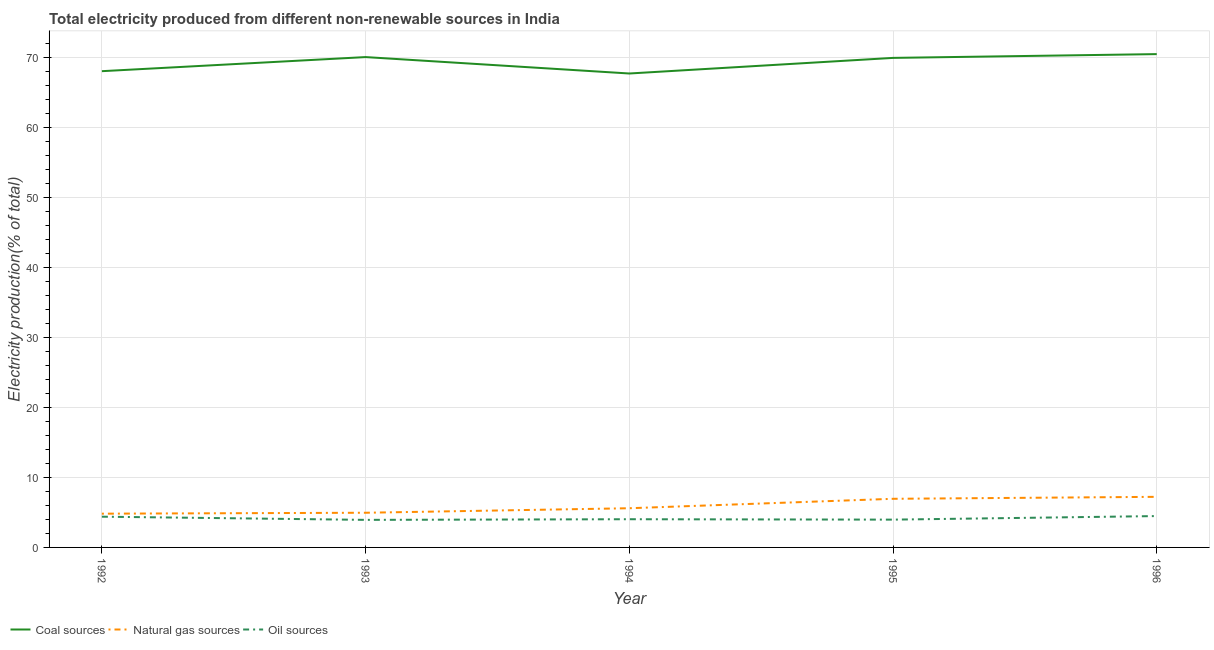How many different coloured lines are there?
Offer a terse response. 3. Does the line corresponding to percentage of electricity produced by oil sources intersect with the line corresponding to percentage of electricity produced by coal?
Give a very brief answer. No. Is the number of lines equal to the number of legend labels?
Offer a terse response. Yes. What is the percentage of electricity produced by oil sources in 1996?
Give a very brief answer. 4.48. Across all years, what is the maximum percentage of electricity produced by oil sources?
Keep it short and to the point. 4.48. Across all years, what is the minimum percentage of electricity produced by natural gas?
Provide a succinct answer. 4.82. In which year was the percentage of electricity produced by coal minimum?
Your answer should be very brief. 1994. What is the total percentage of electricity produced by natural gas in the graph?
Offer a terse response. 29.55. What is the difference between the percentage of electricity produced by oil sources in 1995 and that in 1996?
Your answer should be very brief. -0.51. What is the difference between the percentage of electricity produced by coal in 1995 and the percentage of electricity produced by oil sources in 1996?
Provide a short and direct response. 65.46. What is the average percentage of electricity produced by coal per year?
Give a very brief answer. 69.24. In the year 1992, what is the difference between the percentage of electricity produced by natural gas and percentage of electricity produced by coal?
Your response must be concise. -63.22. What is the ratio of the percentage of electricity produced by coal in 1992 to that in 1995?
Offer a very short reply. 0.97. Is the percentage of electricity produced by natural gas in 1993 less than that in 1994?
Provide a short and direct response. Yes. Is the difference between the percentage of electricity produced by natural gas in 1992 and 1995 greater than the difference between the percentage of electricity produced by coal in 1992 and 1995?
Offer a very short reply. No. What is the difference between the highest and the second highest percentage of electricity produced by natural gas?
Ensure brevity in your answer.  0.28. What is the difference between the highest and the lowest percentage of electricity produced by oil sources?
Make the answer very short. 0.54. Is the sum of the percentage of electricity produced by coal in 1993 and 1996 greater than the maximum percentage of electricity produced by oil sources across all years?
Give a very brief answer. Yes. Is the percentage of electricity produced by coal strictly greater than the percentage of electricity produced by oil sources over the years?
Provide a short and direct response. Yes. Is the percentage of electricity produced by natural gas strictly less than the percentage of electricity produced by oil sources over the years?
Offer a terse response. No. What is the difference between two consecutive major ticks on the Y-axis?
Your answer should be very brief. 10. Are the values on the major ticks of Y-axis written in scientific E-notation?
Offer a very short reply. No. Where does the legend appear in the graph?
Keep it short and to the point. Bottom left. How many legend labels are there?
Offer a very short reply. 3. How are the legend labels stacked?
Offer a very short reply. Horizontal. What is the title of the graph?
Keep it short and to the point. Total electricity produced from different non-renewable sources in India. What is the label or title of the X-axis?
Offer a very short reply. Year. What is the Electricity production(% of total) in Coal sources in 1992?
Your answer should be very brief. 68.04. What is the Electricity production(% of total) of Natural gas sources in 1992?
Your answer should be very brief. 4.82. What is the Electricity production(% of total) in Oil sources in 1992?
Provide a short and direct response. 4.39. What is the Electricity production(% of total) in Coal sources in 1993?
Provide a succinct answer. 70.05. What is the Electricity production(% of total) of Natural gas sources in 1993?
Offer a terse response. 4.95. What is the Electricity production(% of total) of Oil sources in 1993?
Give a very brief answer. 3.94. What is the Electricity production(% of total) in Coal sources in 1994?
Offer a very short reply. 67.71. What is the Electricity production(% of total) in Natural gas sources in 1994?
Make the answer very short. 5.6. What is the Electricity production(% of total) of Oil sources in 1994?
Ensure brevity in your answer.  4.03. What is the Electricity production(% of total) in Coal sources in 1995?
Provide a succinct answer. 69.94. What is the Electricity production(% of total) in Natural gas sources in 1995?
Provide a short and direct response. 6.95. What is the Electricity production(% of total) in Oil sources in 1995?
Ensure brevity in your answer.  3.97. What is the Electricity production(% of total) of Coal sources in 1996?
Your answer should be compact. 70.48. What is the Electricity production(% of total) in Natural gas sources in 1996?
Your response must be concise. 7.23. What is the Electricity production(% of total) in Oil sources in 1996?
Your response must be concise. 4.48. Across all years, what is the maximum Electricity production(% of total) of Coal sources?
Your response must be concise. 70.48. Across all years, what is the maximum Electricity production(% of total) in Natural gas sources?
Your answer should be compact. 7.23. Across all years, what is the maximum Electricity production(% of total) of Oil sources?
Your response must be concise. 4.48. Across all years, what is the minimum Electricity production(% of total) of Coal sources?
Your answer should be very brief. 67.71. Across all years, what is the minimum Electricity production(% of total) of Natural gas sources?
Your answer should be very brief. 4.82. Across all years, what is the minimum Electricity production(% of total) of Oil sources?
Your answer should be very brief. 3.94. What is the total Electricity production(% of total) of Coal sources in the graph?
Offer a very short reply. 346.21. What is the total Electricity production(% of total) of Natural gas sources in the graph?
Keep it short and to the point. 29.55. What is the total Electricity production(% of total) of Oil sources in the graph?
Ensure brevity in your answer.  20.81. What is the difference between the Electricity production(% of total) of Coal sources in 1992 and that in 1993?
Ensure brevity in your answer.  -2.01. What is the difference between the Electricity production(% of total) in Natural gas sources in 1992 and that in 1993?
Your answer should be compact. -0.13. What is the difference between the Electricity production(% of total) of Oil sources in 1992 and that in 1993?
Your answer should be very brief. 0.45. What is the difference between the Electricity production(% of total) in Coal sources in 1992 and that in 1994?
Make the answer very short. 0.33. What is the difference between the Electricity production(% of total) in Natural gas sources in 1992 and that in 1994?
Offer a terse response. -0.78. What is the difference between the Electricity production(% of total) in Oil sources in 1992 and that in 1994?
Your response must be concise. 0.36. What is the difference between the Electricity production(% of total) of Coal sources in 1992 and that in 1995?
Your response must be concise. -1.9. What is the difference between the Electricity production(% of total) of Natural gas sources in 1992 and that in 1995?
Make the answer very short. -2.13. What is the difference between the Electricity production(% of total) of Oil sources in 1992 and that in 1995?
Provide a short and direct response. 0.42. What is the difference between the Electricity production(% of total) of Coal sources in 1992 and that in 1996?
Ensure brevity in your answer.  -2.44. What is the difference between the Electricity production(% of total) of Natural gas sources in 1992 and that in 1996?
Your answer should be very brief. -2.41. What is the difference between the Electricity production(% of total) in Oil sources in 1992 and that in 1996?
Provide a succinct answer. -0.09. What is the difference between the Electricity production(% of total) of Coal sources in 1993 and that in 1994?
Provide a succinct answer. 2.35. What is the difference between the Electricity production(% of total) in Natural gas sources in 1993 and that in 1994?
Give a very brief answer. -0.64. What is the difference between the Electricity production(% of total) of Oil sources in 1993 and that in 1994?
Your answer should be compact. -0.09. What is the difference between the Electricity production(% of total) of Coal sources in 1993 and that in 1995?
Your response must be concise. 0.12. What is the difference between the Electricity production(% of total) of Natural gas sources in 1993 and that in 1995?
Keep it short and to the point. -1.99. What is the difference between the Electricity production(% of total) of Oil sources in 1993 and that in 1995?
Provide a short and direct response. -0.03. What is the difference between the Electricity production(% of total) of Coal sources in 1993 and that in 1996?
Your answer should be very brief. -0.42. What is the difference between the Electricity production(% of total) in Natural gas sources in 1993 and that in 1996?
Give a very brief answer. -2.27. What is the difference between the Electricity production(% of total) of Oil sources in 1993 and that in 1996?
Offer a terse response. -0.54. What is the difference between the Electricity production(% of total) of Coal sources in 1994 and that in 1995?
Make the answer very short. -2.23. What is the difference between the Electricity production(% of total) in Natural gas sources in 1994 and that in 1995?
Your response must be concise. -1.35. What is the difference between the Electricity production(% of total) in Oil sources in 1994 and that in 1995?
Give a very brief answer. 0.06. What is the difference between the Electricity production(% of total) of Coal sources in 1994 and that in 1996?
Provide a succinct answer. -2.77. What is the difference between the Electricity production(% of total) of Natural gas sources in 1994 and that in 1996?
Keep it short and to the point. -1.63. What is the difference between the Electricity production(% of total) of Oil sources in 1994 and that in 1996?
Your response must be concise. -0.45. What is the difference between the Electricity production(% of total) in Coal sources in 1995 and that in 1996?
Your answer should be very brief. -0.54. What is the difference between the Electricity production(% of total) of Natural gas sources in 1995 and that in 1996?
Keep it short and to the point. -0.28. What is the difference between the Electricity production(% of total) in Oil sources in 1995 and that in 1996?
Your answer should be very brief. -0.51. What is the difference between the Electricity production(% of total) of Coal sources in 1992 and the Electricity production(% of total) of Natural gas sources in 1993?
Ensure brevity in your answer.  63.08. What is the difference between the Electricity production(% of total) of Coal sources in 1992 and the Electricity production(% of total) of Oil sources in 1993?
Provide a short and direct response. 64.1. What is the difference between the Electricity production(% of total) of Natural gas sources in 1992 and the Electricity production(% of total) of Oil sources in 1993?
Your answer should be compact. 0.88. What is the difference between the Electricity production(% of total) in Coal sources in 1992 and the Electricity production(% of total) in Natural gas sources in 1994?
Your response must be concise. 62.44. What is the difference between the Electricity production(% of total) of Coal sources in 1992 and the Electricity production(% of total) of Oil sources in 1994?
Provide a short and direct response. 64.01. What is the difference between the Electricity production(% of total) of Natural gas sources in 1992 and the Electricity production(% of total) of Oil sources in 1994?
Your answer should be compact. 0.79. What is the difference between the Electricity production(% of total) of Coal sources in 1992 and the Electricity production(% of total) of Natural gas sources in 1995?
Offer a very short reply. 61.09. What is the difference between the Electricity production(% of total) in Coal sources in 1992 and the Electricity production(% of total) in Oil sources in 1995?
Offer a terse response. 64.07. What is the difference between the Electricity production(% of total) in Natural gas sources in 1992 and the Electricity production(% of total) in Oil sources in 1995?
Provide a succinct answer. 0.85. What is the difference between the Electricity production(% of total) in Coal sources in 1992 and the Electricity production(% of total) in Natural gas sources in 1996?
Offer a very short reply. 60.81. What is the difference between the Electricity production(% of total) of Coal sources in 1992 and the Electricity production(% of total) of Oil sources in 1996?
Your response must be concise. 63.56. What is the difference between the Electricity production(% of total) in Natural gas sources in 1992 and the Electricity production(% of total) in Oil sources in 1996?
Keep it short and to the point. 0.34. What is the difference between the Electricity production(% of total) of Coal sources in 1993 and the Electricity production(% of total) of Natural gas sources in 1994?
Your response must be concise. 64.45. What is the difference between the Electricity production(% of total) of Coal sources in 1993 and the Electricity production(% of total) of Oil sources in 1994?
Make the answer very short. 66.02. What is the difference between the Electricity production(% of total) in Natural gas sources in 1993 and the Electricity production(% of total) in Oil sources in 1994?
Your answer should be compact. 0.93. What is the difference between the Electricity production(% of total) in Coal sources in 1993 and the Electricity production(% of total) in Natural gas sources in 1995?
Your answer should be compact. 63.11. What is the difference between the Electricity production(% of total) of Coal sources in 1993 and the Electricity production(% of total) of Oil sources in 1995?
Offer a very short reply. 66.08. What is the difference between the Electricity production(% of total) of Natural gas sources in 1993 and the Electricity production(% of total) of Oil sources in 1995?
Your answer should be very brief. 0.98. What is the difference between the Electricity production(% of total) of Coal sources in 1993 and the Electricity production(% of total) of Natural gas sources in 1996?
Provide a short and direct response. 62.83. What is the difference between the Electricity production(% of total) in Coal sources in 1993 and the Electricity production(% of total) in Oil sources in 1996?
Keep it short and to the point. 65.57. What is the difference between the Electricity production(% of total) of Natural gas sources in 1993 and the Electricity production(% of total) of Oil sources in 1996?
Ensure brevity in your answer.  0.47. What is the difference between the Electricity production(% of total) of Coal sources in 1994 and the Electricity production(% of total) of Natural gas sources in 1995?
Your response must be concise. 60.76. What is the difference between the Electricity production(% of total) of Coal sources in 1994 and the Electricity production(% of total) of Oil sources in 1995?
Give a very brief answer. 63.74. What is the difference between the Electricity production(% of total) of Natural gas sources in 1994 and the Electricity production(% of total) of Oil sources in 1995?
Keep it short and to the point. 1.63. What is the difference between the Electricity production(% of total) in Coal sources in 1994 and the Electricity production(% of total) in Natural gas sources in 1996?
Keep it short and to the point. 60.48. What is the difference between the Electricity production(% of total) in Coal sources in 1994 and the Electricity production(% of total) in Oil sources in 1996?
Keep it short and to the point. 63.23. What is the difference between the Electricity production(% of total) of Natural gas sources in 1994 and the Electricity production(% of total) of Oil sources in 1996?
Provide a short and direct response. 1.12. What is the difference between the Electricity production(% of total) in Coal sources in 1995 and the Electricity production(% of total) in Natural gas sources in 1996?
Give a very brief answer. 62.71. What is the difference between the Electricity production(% of total) in Coal sources in 1995 and the Electricity production(% of total) in Oil sources in 1996?
Give a very brief answer. 65.46. What is the difference between the Electricity production(% of total) of Natural gas sources in 1995 and the Electricity production(% of total) of Oil sources in 1996?
Provide a short and direct response. 2.47. What is the average Electricity production(% of total) of Coal sources per year?
Give a very brief answer. 69.24. What is the average Electricity production(% of total) in Natural gas sources per year?
Provide a short and direct response. 5.91. What is the average Electricity production(% of total) in Oil sources per year?
Provide a short and direct response. 4.16. In the year 1992, what is the difference between the Electricity production(% of total) of Coal sources and Electricity production(% of total) of Natural gas sources?
Your answer should be very brief. 63.22. In the year 1992, what is the difference between the Electricity production(% of total) of Coal sources and Electricity production(% of total) of Oil sources?
Provide a succinct answer. 63.65. In the year 1992, what is the difference between the Electricity production(% of total) of Natural gas sources and Electricity production(% of total) of Oil sources?
Make the answer very short. 0.43. In the year 1993, what is the difference between the Electricity production(% of total) of Coal sources and Electricity production(% of total) of Natural gas sources?
Your answer should be very brief. 65.1. In the year 1993, what is the difference between the Electricity production(% of total) of Coal sources and Electricity production(% of total) of Oil sources?
Offer a very short reply. 66.12. In the year 1993, what is the difference between the Electricity production(% of total) of Natural gas sources and Electricity production(% of total) of Oil sources?
Make the answer very short. 1.02. In the year 1994, what is the difference between the Electricity production(% of total) of Coal sources and Electricity production(% of total) of Natural gas sources?
Your response must be concise. 62.11. In the year 1994, what is the difference between the Electricity production(% of total) in Coal sources and Electricity production(% of total) in Oil sources?
Offer a terse response. 63.68. In the year 1994, what is the difference between the Electricity production(% of total) of Natural gas sources and Electricity production(% of total) of Oil sources?
Provide a short and direct response. 1.57. In the year 1995, what is the difference between the Electricity production(% of total) of Coal sources and Electricity production(% of total) of Natural gas sources?
Ensure brevity in your answer.  62.99. In the year 1995, what is the difference between the Electricity production(% of total) of Coal sources and Electricity production(% of total) of Oil sources?
Give a very brief answer. 65.97. In the year 1995, what is the difference between the Electricity production(% of total) of Natural gas sources and Electricity production(% of total) of Oil sources?
Give a very brief answer. 2.98. In the year 1996, what is the difference between the Electricity production(% of total) in Coal sources and Electricity production(% of total) in Natural gas sources?
Provide a succinct answer. 63.25. In the year 1996, what is the difference between the Electricity production(% of total) in Coal sources and Electricity production(% of total) in Oil sources?
Ensure brevity in your answer.  66. In the year 1996, what is the difference between the Electricity production(% of total) in Natural gas sources and Electricity production(% of total) in Oil sources?
Keep it short and to the point. 2.75. What is the ratio of the Electricity production(% of total) of Coal sources in 1992 to that in 1993?
Ensure brevity in your answer.  0.97. What is the ratio of the Electricity production(% of total) in Natural gas sources in 1992 to that in 1993?
Your response must be concise. 0.97. What is the ratio of the Electricity production(% of total) in Oil sources in 1992 to that in 1993?
Provide a short and direct response. 1.12. What is the ratio of the Electricity production(% of total) of Coal sources in 1992 to that in 1994?
Offer a terse response. 1. What is the ratio of the Electricity production(% of total) in Natural gas sources in 1992 to that in 1994?
Your response must be concise. 0.86. What is the ratio of the Electricity production(% of total) in Oil sources in 1992 to that in 1994?
Your response must be concise. 1.09. What is the ratio of the Electricity production(% of total) in Coal sources in 1992 to that in 1995?
Provide a succinct answer. 0.97. What is the ratio of the Electricity production(% of total) in Natural gas sources in 1992 to that in 1995?
Your answer should be very brief. 0.69. What is the ratio of the Electricity production(% of total) in Oil sources in 1992 to that in 1995?
Keep it short and to the point. 1.11. What is the ratio of the Electricity production(% of total) in Coal sources in 1992 to that in 1996?
Give a very brief answer. 0.97. What is the ratio of the Electricity production(% of total) in Natural gas sources in 1992 to that in 1996?
Provide a succinct answer. 0.67. What is the ratio of the Electricity production(% of total) in Oil sources in 1992 to that in 1996?
Offer a very short reply. 0.98. What is the ratio of the Electricity production(% of total) in Coal sources in 1993 to that in 1994?
Provide a short and direct response. 1.03. What is the ratio of the Electricity production(% of total) in Natural gas sources in 1993 to that in 1994?
Provide a short and direct response. 0.88. What is the ratio of the Electricity production(% of total) of Oil sources in 1993 to that in 1994?
Your answer should be very brief. 0.98. What is the ratio of the Electricity production(% of total) in Natural gas sources in 1993 to that in 1995?
Make the answer very short. 0.71. What is the ratio of the Electricity production(% of total) in Oil sources in 1993 to that in 1995?
Provide a succinct answer. 0.99. What is the ratio of the Electricity production(% of total) of Natural gas sources in 1993 to that in 1996?
Make the answer very short. 0.69. What is the ratio of the Electricity production(% of total) in Oil sources in 1993 to that in 1996?
Give a very brief answer. 0.88. What is the ratio of the Electricity production(% of total) in Coal sources in 1994 to that in 1995?
Offer a very short reply. 0.97. What is the ratio of the Electricity production(% of total) of Natural gas sources in 1994 to that in 1995?
Give a very brief answer. 0.81. What is the ratio of the Electricity production(% of total) of Oil sources in 1994 to that in 1995?
Your answer should be very brief. 1.01. What is the ratio of the Electricity production(% of total) of Coal sources in 1994 to that in 1996?
Ensure brevity in your answer.  0.96. What is the ratio of the Electricity production(% of total) in Natural gas sources in 1994 to that in 1996?
Offer a terse response. 0.77. What is the ratio of the Electricity production(% of total) of Oil sources in 1994 to that in 1996?
Provide a short and direct response. 0.9. What is the ratio of the Electricity production(% of total) in Natural gas sources in 1995 to that in 1996?
Ensure brevity in your answer.  0.96. What is the ratio of the Electricity production(% of total) of Oil sources in 1995 to that in 1996?
Your answer should be very brief. 0.89. What is the difference between the highest and the second highest Electricity production(% of total) in Coal sources?
Provide a short and direct response. 0.42. What is the difference between the highest and the second highest Electricity production(% of total) in Natural gas sources?
Your answer should be very brief. 0.28. What is the difference between the highest and the second highest Electricity production(% of total) in Oil sources?
Ensure brevity in your answer.  0.09. What is the difference between the highest and the lowest Electricity production(% of total) of Coal sources?
Offer a terse response. 2.77. What is the difference between the highest and the lowest Electricity production(% of total) of Natural gas sources?
Provide a short and direct response. 2.41. What is the difference between the highest and the lowest Electricity production(% of total) of Oil sources?
Offer a very short reply. 0.54. 